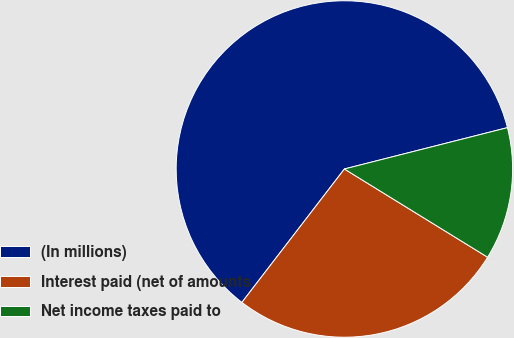<chart> <loc_0><loc_0><loc_500><loc_500><pie_chart><fcel>(In millions)<fcel>Interest paid (net of amounts<fcel>Net income taxes paid to<nl><fcel>60.62%<fcel>26.64%<fcel>12.74%<nl></chart> 